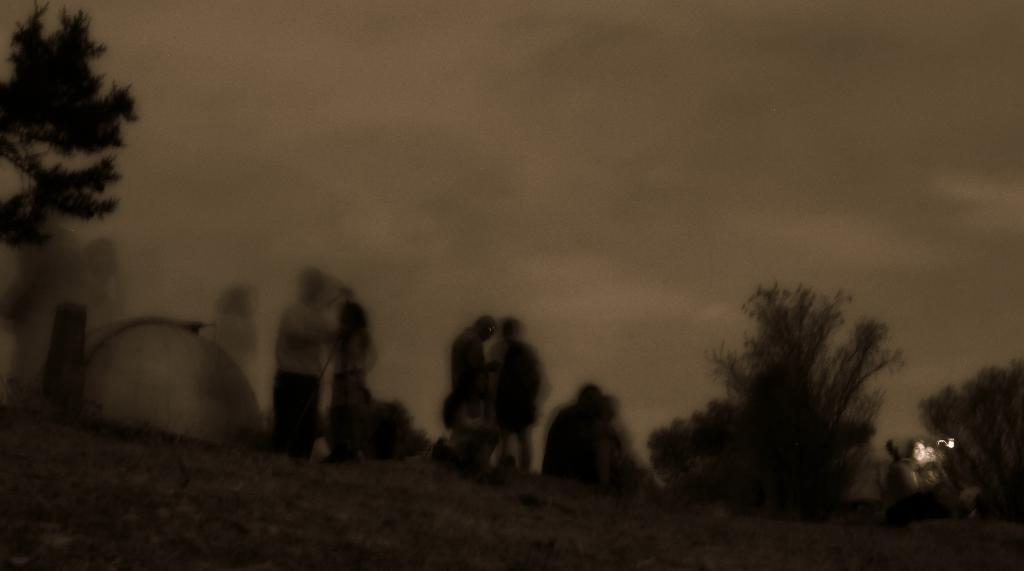Who or what is present in the image? There are people in the image. What else can be seen in the image besides the people? There are plants in the image. What is visible at the top of the image? The sky is visible at the top of the image. What song is being sung by the plants in the image? There are no plants singing in the image; plants do not have the ability to sing. 